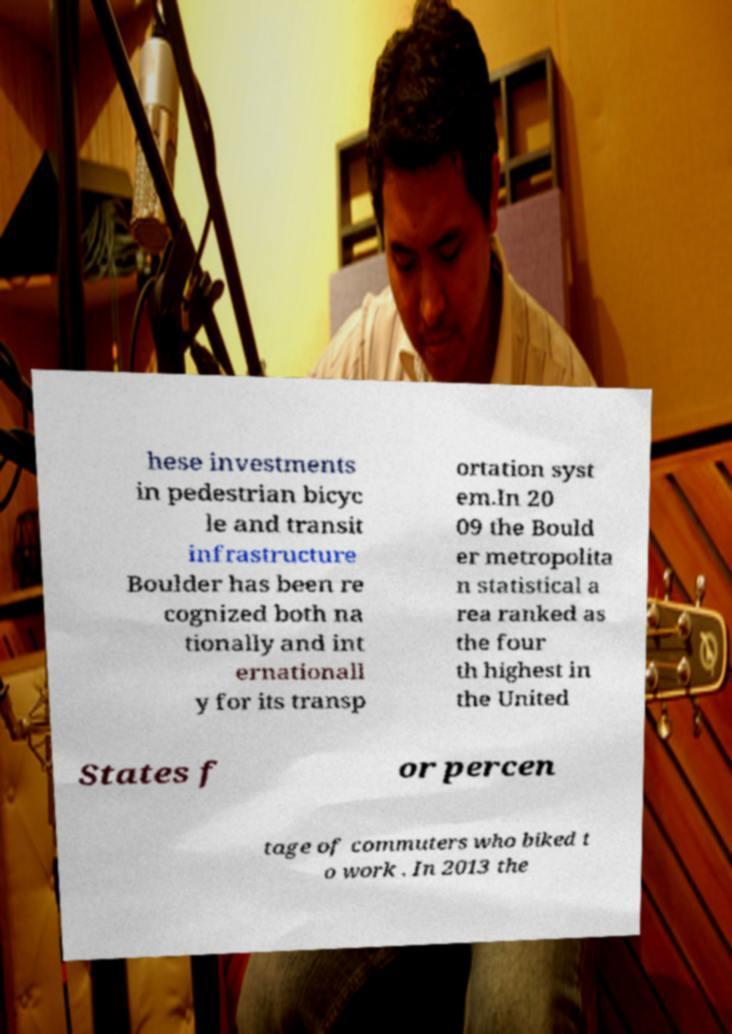For documentation purposes, I need the text within this image transcribed. Could you provide that? hese investments in pedestrian bicyc le and transit infrastructure Boulder has been re cognized both na tionally and int ernationall y for its transp ortation syst em.In 20 09 the Bould er metropolita n statistical a rea ranked as the four th highest in the United States f or percen tage of commuters who biked t o work . In 2013 the 